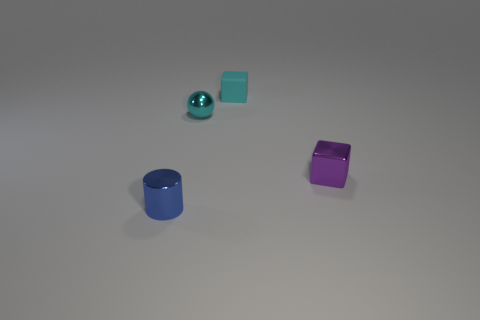Is the cyan sphere the same size as the purple object?
Ensure brevity in your answer.  Yes. Does the small metallic thing that is behind the purple block have the same color as the tiny shiny cylinder?
Your answer should be very brief. No. How many purple metallic objects are left of the matte object?
Your answer should be compact. 0. Is the number of green metallic cylinders greater than the number of tiny cyan metallic objects?
Provide a succinct answer. No. What shape is the object that is right of the small cyan metal sphere and behind the small purple cube?
Keep it short and to the point. Cube. Are there any tiny cyan rubber objects?
Give a very brief answer. Yes. There is another object that is the same shape as the purple shiny thing; what is it made of?
Provide a short and direct response. Rubber. There is a tiny metal object that is in front of the block in front of the cyan object in front of the cyan block; what shape is it?
Offer a terse response. Cylinder. What material is the small cube that is the same color as the tiny ball?
Make the answer very short. Rubber. What number of other tiny cyan things have the same shape as the matte object?
Your answer should be compact. 0. 